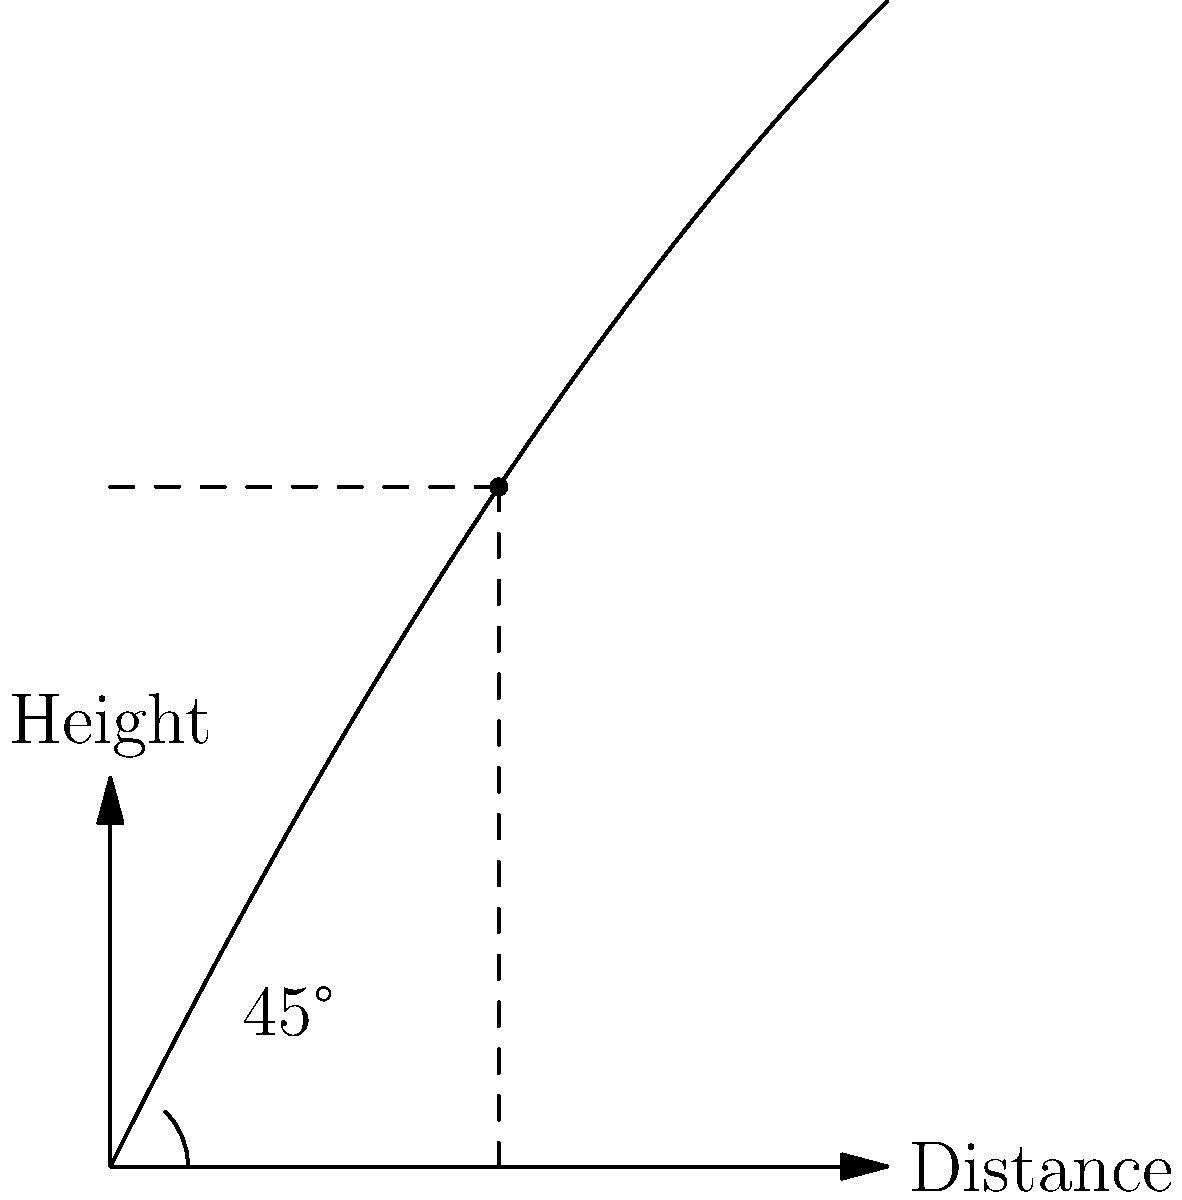As a fitness trainer incorporating math concepts into your workshops, you're teaching students about the physics of long jump. Using the parabolic trajectory diagram provided, what is the optimal angle for achieving the maximum distance in a long jump, and why is this angle considered optimal? To determine the optimal angle for a long jump, we need to consider the principles of projectile motion:

1. The trajectory of a long jump can be modeled as a parabola, as shown in the diagram.

2. The range (horizontal distance) of a projectile is given by the equation:
   $$R = \frac{v^2 \sin(2\theta)}{g}$$
   where $R$ is the range, $v$ is the initial velocity, $\theta$ is the launch angle, and $g$ is the acceleration due to gravity.

3. To maximize the range, we need to maximize $\sin(2\theta)$.

4. The sine function reaches its maximum value of 1 when its argument is 90°.

5. Therefore, $2\theta = 90°$, or $\theta = 45°$.

6. This 45° angle is shown in the diagram at the start of the trajectory.

7. The 45° angle provides an optimal balance between horizontal and vertical components of velocity:
   - It gives enough height for the jumper to stay in the air longer.
   - It also maintains sufficient horizontal velocity to cover a greater distance.

8. In practice, the optimal angle might be slightly less than 45° due to factors like air resistance and the jumper's running speed, but 45° is the theoretical optimum for an idealized projectile.
Answer: 45° 